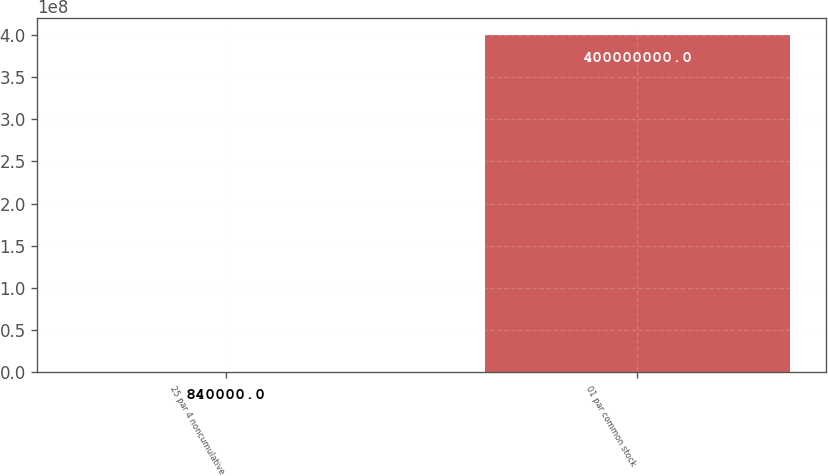<chart> <loc_0><loc_0><loc_500><loc_500><bar_chart><fcel>25 par 4 noncumulative<fcel>01 par common stock<nl><fcel>840000<fcel>4e+08<nl></chart> 